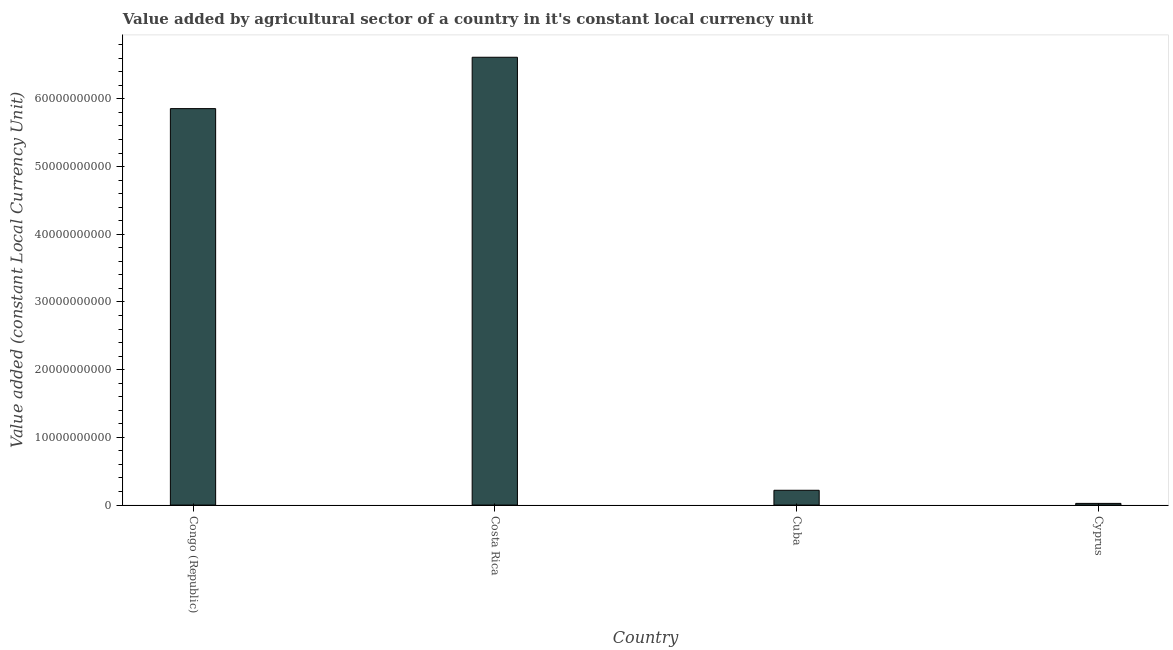Does the graph contain any zero values?
Offer a terse response. No. Does the graph contain grids?
Make the answer very short. No. What is the title of the graph?
Ensure brevity in your answer.  Value added by agricultural sector of a country in it's constant local currency unit. What is the label or title of the X-axis?
Give a very brief answer. Country. What is the label or title of the Y-axis?
Offer a terse response. Value added (constant Local Currency Unit). What is the value added by agriculture sector in Cuba?
Your answer should be compact. 2.19e+09. Across all countries, what is the maximum value added by agriculture sector?
Your answer should be very brief. 6.62e+1. Across all countries, what is the minimum value added by agriculture sector?
Provide a short and direct response. 2.48e+08. In which country was the value added by agriculture sector minimum?
Offer a very short reply. Cyprus. What is the sum of the value added by agriculture sector?
Provide a succinct answer. 1.27e+11. What is the difference between the value added by agriculture sector in Costa Rica and Cuba?
Your answer should be compact. 6.40e+1. What is the average value added by agriculture sector per country?
Ensure brevity in your answer.  3.18e+1. What is the median value added by agriculture sector?
Your response must be concise. 3.04e+1. In how many countries, is the value added by agriculture sector greater than 40000000000 LCU?
Provide a short and direct response. 2. What is the ratio of the value added by agriculture sector in Congo (Republic) to that in Costa Rica?
Your answer should be very brief. 0.89. Is the difference between the value added by agriculture sector in Congo (Republic) and Costa Rica greater than the difference between any two countries?
Offer a terse response. No. What is the difference between the highest and the second highest value added by agriculture sector?
Keep it short and to the point. 7.59e+09. Is the sum of the value added by agriculture sector in Cuba and Cyprus greater than the maximum value added by agriculture sector across all countries?
Make the answer very short. No. What is the difference between the highest and the lowest value added by agriculture sector?
Offer a very short reply. 6.59e+1. In how many countries, is the value added by agriculture sector greater than the average value added by agriculture sector taken over all countries?
Ensure brevity in your answer.  2. How many bars are there?
Provide a succinct answer. 4. Are all the bars in the graph horizontal?
Your answer should be compact. No. What is the difference between two consecutive major ticks on the Y-axis?
Offer a very short reply. 1.00e+1. What is the Value added (constant Local Currency Unit) in Congo (Republic)?
Provide a short and direct response. 5.86e+1. What is the Value added (constant Local Currency Unit) in Costa Rica?
Your answer should be very brief. 6.62e+1. What is the Value added (constant Local Currency Unit) in Cuba?
Make the answer very short. 2.19e+09. What is the Value added (constant Local Currency Unit) in Cyprus?
Make the answer very short. 2.48e+08. What is the difference between the Value added (constant Local Currency Unit) in Congo (Republic) and Costa Rica?
Your answer should be very brief. -7.59e+09. What is the difference between the Value added (constant Local Currency Unit) in Congo (Republic) and Cuba?
Ensure brevity in your answer.  5.64e+1. What is the difference between the Value added (constant Local Currency Unit) in Congo (Republic) and Cyprus?
Give a very brief answer. 5.83e+1. What is the difference between the Value added (constant Local Currency Unit) in Costa Rica and Cuba?
Your response must be concise. 6.40e+1. What is the difference between the Value added (constant Local Currency Unit) in Costa Rica and Cyprus?
Offer a terse response. 6.59e+1. What is the difference between the Value added (constant Local Currency Unit) in Cuba and Cyprus?
Offer a very short reply. 1.94e+09. What is the ratio of the Value added (constant Local Currency Unit) in Congo (Republic) to that in Costa Rica?
Make the answer very short. 0.89. What is the ratio of the Value added (constant Local Currency Unit) in Congo (Republic) to that in Cuba?
Offer a very short reply. 26.78. What is the ratio of the Value added (constant Local Currency Unit) in Congo (Republic) to that in Cyprus?
Give a very brief answer. 236.6. What is the ratio of the Value added (constant Local Currency Unit) in Costa Rica to that in Cuba?
Your answer should be compact. 30.25. What is the ratio of the Value added (constant Local Currency Unit) in Costa Rica to that in Cyprus?
Your answer should be compact. 267.25. What is the ratio of the Value added (constant Local Currency Unit) in Cuba to that in Cyprus?
Offer a terse response. 8.84. 